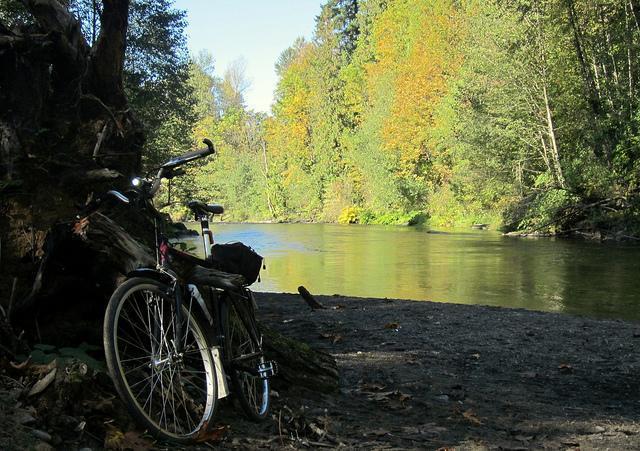How many suv cars are in the picture?
Give a very brief answer. 0. 